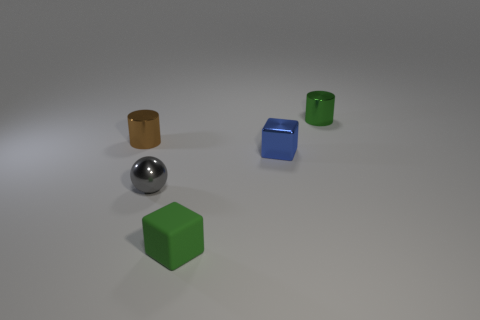Add 4 small brown things. How many objects exist? 9 Subtract all spheres. How many objects are left? 4 Add 2 small blue shiny cubes. How many small blue shiny cubes are left? 3 Add 5 tiny green shiny things. How many tiny green shiny things exist? 6 Subtract 0 yellow cubes. How many objects are left? 5 Subtract all small blue metal balls. Subtract all blue blocks. How many objects are left? 4 